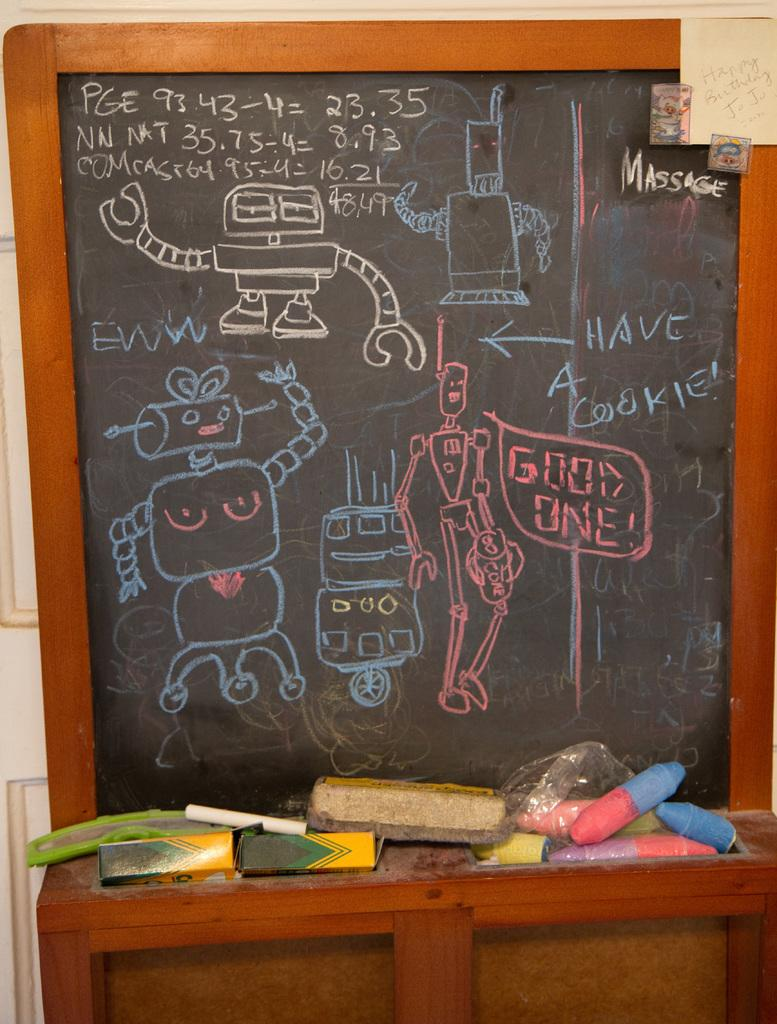<image>
Create a compact narrative representing the image presented. Drawings of robots on a black board including one in red saying good one. 